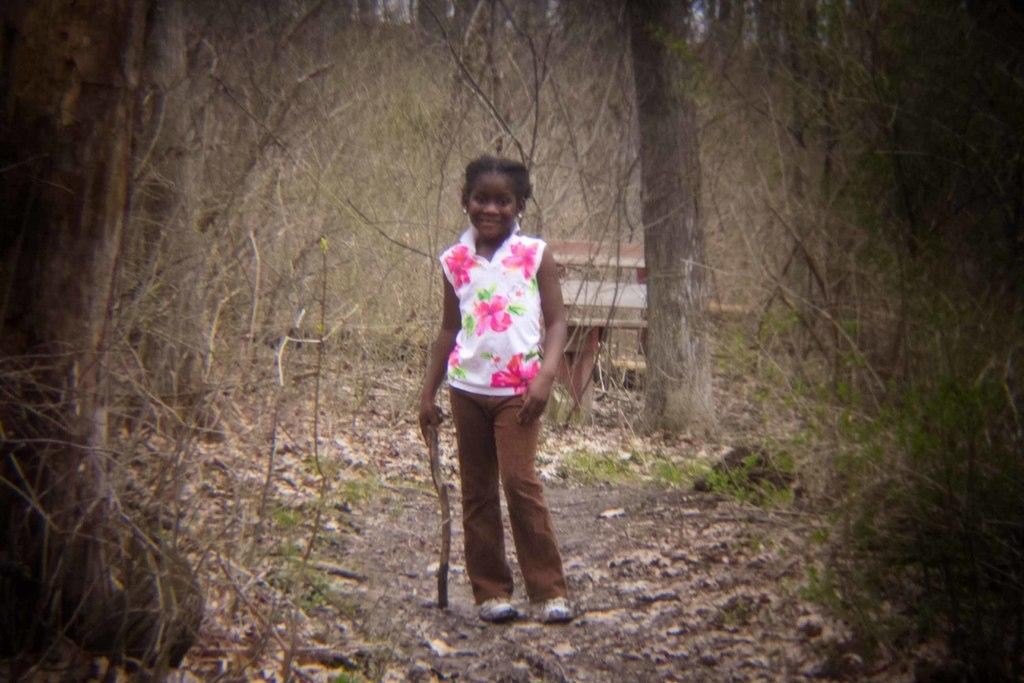Who is the main subject in the image? There is a girl in the image. What is the girl holding in her hand? The girl is holding a stick. What can be seen on the ground in the image? Dried leaves are present on the ground. What is visible in the background of the image? There are many trees in the background of the image. What type of insurance policy is the girl discussing in the image? There is no indication in the image that the girl is discussing any insurance policy. 